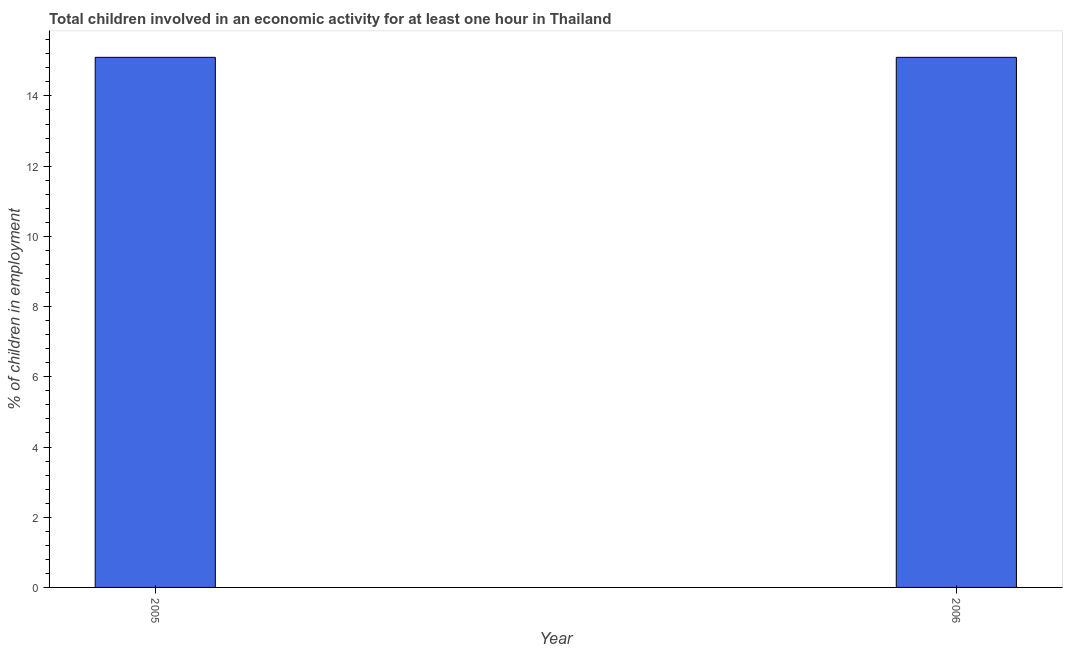Does the graph contain any zero values?
Offer a terse response. No. What is the title of the graph?
Offer a terse response. Total children involved in an economic activity for at least one hour in Thailand. What is the label or title of the Y-axis?
Make the answer very short. % of children in employment. Across all years, what is the maximum percentage of children in employment?
Make the answer very short. 15.1. Across all years, what is the minimum percentage of children in employment?
Your answer should be compact. 15.1. In which year was the percentage of children in employment maximum?
Your answer should be compact. 2005. What is the sum of the percentage of children in employment?
Ensure brevity in your answer.  30.2. What is the difference between the percentage of children in employment in 2005 and 2006?
Ensure brevity in your answer.  0. What is the ratio of the percentage of children in employment in 2005 to that in 2006?
Your response must be concise. 1. In how many years, is the percentage of children in employment greater than the average percentage of children in employment taken over all years?
Your answer should be very brief. 0. How many bars are there?
Keep it short and to the point. 2. Are all the bars in the graph horizontal?
Provide a succinct answer. No. How many years are there in the graph?
Offer a terse response. 2. What is the difference between two consecutive major ticks on the Y-axis?
Your answer should be compact. 2. Are the values on the major ticks of Y-axis written in scientific E-notation?
Offer a terse response. No. What is the % of children in employment in 2005?
Provide a short and direct response. 15.1. What is the % of children in employment of 2006?
Offer a very short reply. 15.1. What is the ratio of the % of children in employment in 2005 to that in 2006?
Your answer should be compact. 1. 